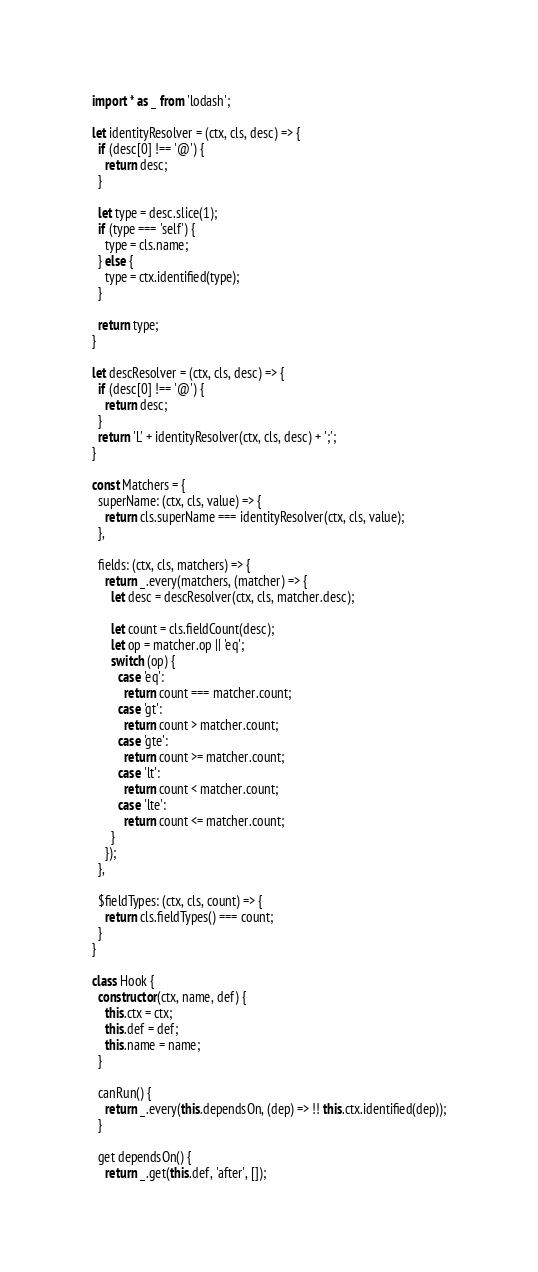Convert code to text. <code><loc_0><loc_0><loc_500><loc_500><_JavaScript_>import * as _ from 'lodash';

let identityResolver = (ctx, cls, desc) => {
  if (desc[0] !== '@') {
    return desc;
  }

  let type = desc.slice(1);
  if (type === 'self') {
    type = cls.name;
  } else {
    type = ctx.identified(type);
  }

  return type;
}

let descResolver = (ctx, cls, desc) => {
  if (desc[0] !== '@') {
    return desc;
  }
  return 'L' + identityResolver(ctx, cls, desc) + ';';
}

const Matchers = {
  superName: (ctx, cls, value) => {
    return cls.superName === identityResolver(ctx, cls, value);
  },

  fields: (ctx, cls, matchers) => {
    return _.every(matchers, (matcher) => {
      let desc = descResolver(ctx, cls, matcher.desc);

      let count = cls.fieldCount(desc);
      let op = matcher.op || 'eq';
      switch (op) {
        case 'eq':
          return count === matcher.count;
        case 'gt':
          return count > matcher.count;
        case 'gte':
          return count >= matcher.count;
        case 'lt':
          return count < matcher.count;
        case 'lte':
          return count <= matcher.count;
      }
    });
  },

  $fieldTypes: (ctx, cls, count) => {
    return cls.fieldTypes() === count;
  }
}

class Hook {
  constructor(ctx, name, def) {
    this.ctx = ctx;
    this.def = def;
    this.name = name;
  }

  canRun() {
    return _.every(this.dependsOn, (dep) => !! this.ctx.identified(dep));
  }

  get dependsOn() {
    return _.get(this.def, 'after', []);</code> 